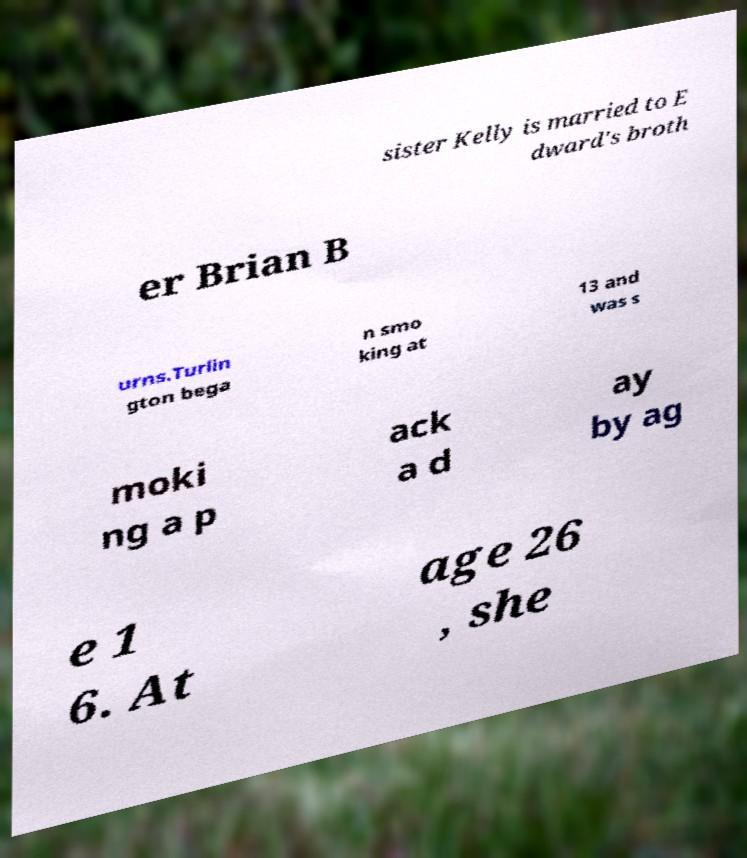What messages or text are displayed in this image? I need them in a readable, typed format. sister Kelly is married to E dward's broth er Brian B urns.Turlin gton bega n smo king at 13 and was s moki ng a p ack a d ay by ag e 1 6. At age 26 , she 